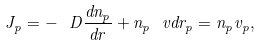Convert formula to latex. <formula><loc_0><loc_0><loc_500><loc_500>J _ { p } = - \ D \frac { d n _ { p } } { d r } + n _ { p } \ v d r _ { p } = n _ { p } v _ { p } ,</formula> 